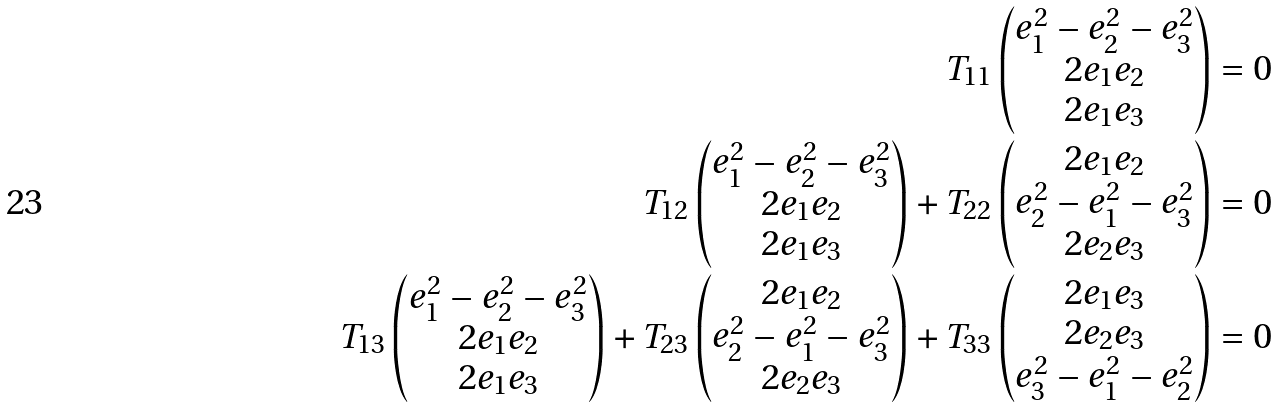<formula> <loc_0><loc_0><loc_500><loc_500>T _ { 1 1 } \begin{pmatrix} e _ { 1 } ^ { 2 } - e _ { 2 } ^ { 2 } - e _ { 3 } ^ { 2 } \\ 2 e _ { 1 } e _ { 2 } \\ 2 e _ { 1 } e _ { 3 } \end{pmatrix} = 0 \\ T _ { 1 2 } \begin{pmatrix} e _ { 1 } ^ { 2 } - e _ { 2 } ^ { 2 } - e _ { 3 } ^ { 2 } \\ 2 e _ { 1 } e _ { 2 } \\ 2 e _ { 1 } e _ { 3 } \end{pmatrix} + T _ { 2 2 } \begin{pmatrix} 2 e _ { 1 } e _ { 2 } \\ e _ { 2 } ^ { 2 } - e _ { 1 } ^ { 2 } - e _ { 3 } ^ { 2 } \\ 2 e _ { 2 } e _ { 3 } \end{pmatrix} = 0 \\ T _ { 1 3 } \begin{pmatrix} e _ { 1 } ^ { 2 } - e _ { 2 } ^ { 2 } - e _ { 3 } ^ { 2 } \\ 2 e _ { 1 } e _ { 2 } \\ 2 e _ { 1 } e _ { 3 } \end{pmatrix} + T _ { 2 3 } \begin{pmatrix} 2 e _ { 1 } e _ { 2 } \\ e _ { 2 } ^ { 2 } - e _ { 1 } ^ { 2 } - e _ { 3 } ^ { 2 } \\ 2 e _ { 2 } e _ { 3 } \end{pmatrix} + T _ { 3 3 } \begin{pmatrix} 2 e _ { 1 } e _ { 3 } \\ 2 e _ { 2 } e _ { 3 } \\ e _ { 3 } ^ { 2 } - e _ { 1 } ^ { 2 } - e _ { 2 } ^ { 2 } \end{pmatrix} = 0</formula> 